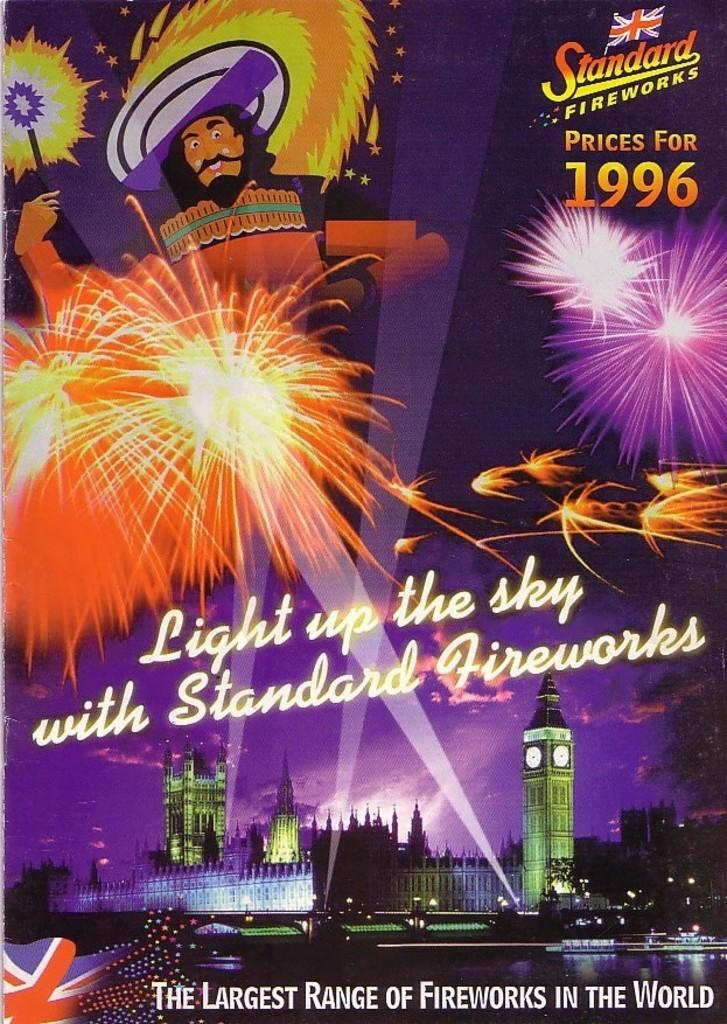<image>
Write a terse but informative summary of the picture. an advertisement with the word light on it 